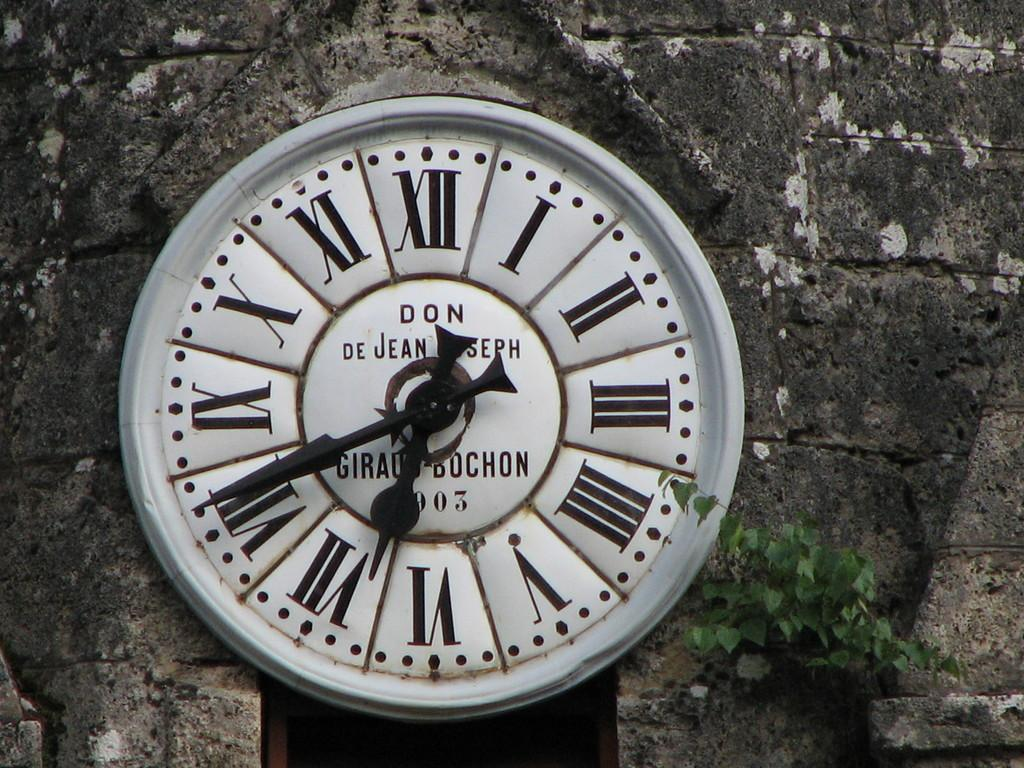<image>
Give a short and clear explanation of the subsequent image. A round clock face that says Don De Jean Joseph on it. 